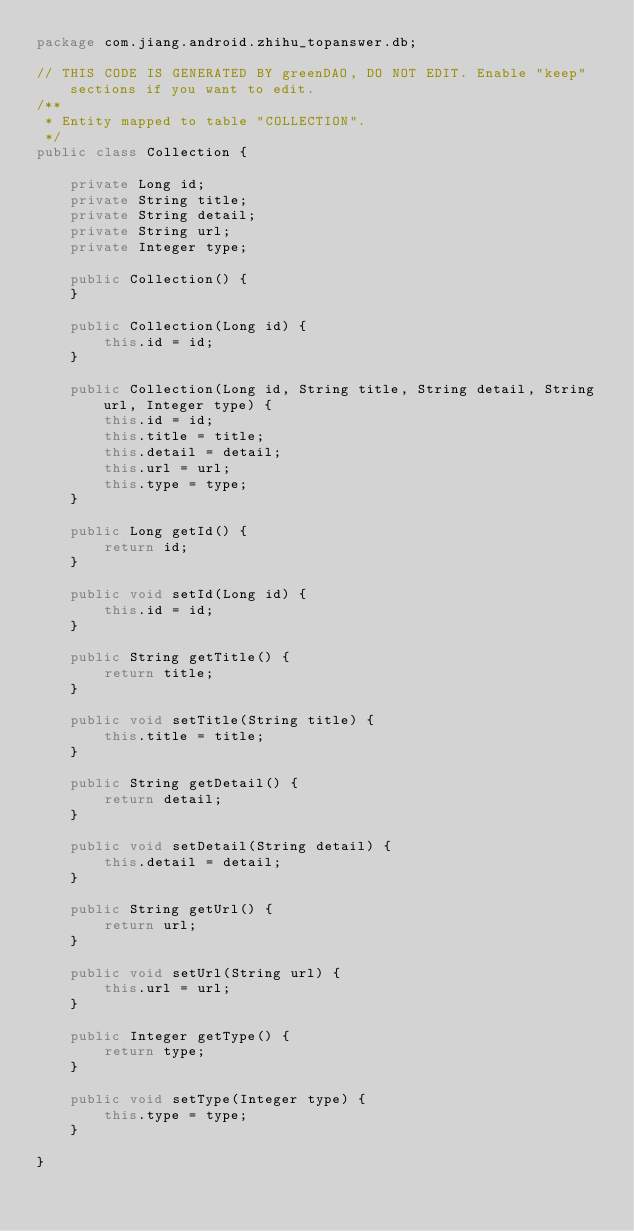<code> <loc_0><loc_0><loc_500><loc_500><_Java_>package com.jiang.android.zhihu_topanswer.db;

// THIS CODE IS GENERATED BY greenDAO, DO NOT EDIT. Enable "keep" sections if you want to edit. 
/**
 * Entity mapped to table "COLLECTION".
 */
public class Collection {

    private Long id;
    private String title;
    private String detail;
    private String url;
    private Integer type;

    public Collection() {
    }

    public Collection(Long id) {
        this.id = id;
    }

    public Collection(Long id, String title, String detail, String url, Integer type) {
        this.id = id;
        this.title = title;
        this.detail = detail;
        this.url = url;
        this.type = type;
    }

    public Long getId() {
        return id;
    }

    public void setId(Long id) {
        this.id = id;
    }

    public String getTitle() {
        return title;
    }

    public void setTitle(String title) {
        this.title = title;
    }

    public String getDetail() {
        return detail;
    }

    public void setDetail(String detail) {
        this.detail = detail;
    }

    public String getUrl() {
        return url;
    }

    public void setUrl(String url) {
        this.url = url;
    }

    public Integer getType() {
        return type;
    }

    public void setType(Integer type) {
        this.type = type;
    }

}
</code> 